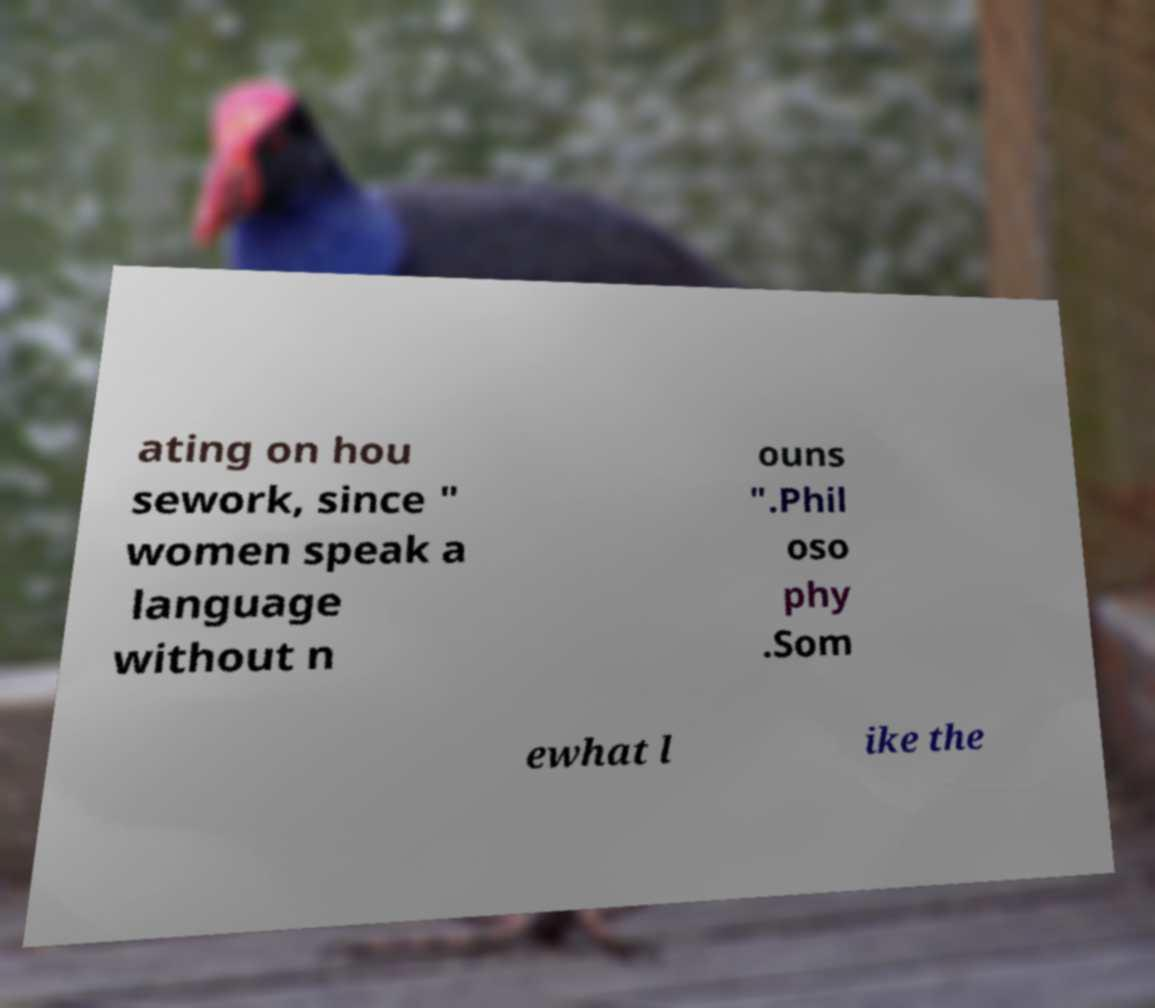There's text embedded in this image that I need extracted. Can you transcribe it verbatim? ating on hou sework, since " women speak a language without n ouns ".Phil oso phy .Som ewhat l ike the 